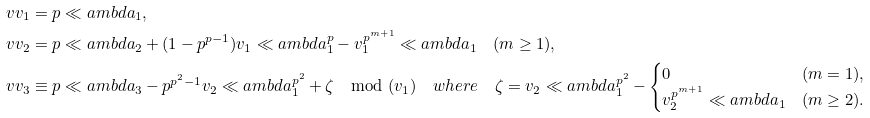Convert formula to latex. <formula><loc_0><loc_0><loc_500><loc_500>\ v v _ { 1 } & = p \ll a m b d a _ { 1 } , \\ \ v v _ { 2 } & = p \ll a m b d a _ { 2 } + ( 1 - p ^ { p - 1 } ) v _ { 1 } \ll a m b d a _ { 1 } ^ { p } - v _ { 1 } ^ { p ^ { m + 1 } } \ll a m b d a _ { 1 } \quad ( m \geq 1 ) , \\ \ v v _ { 3 } & \equiv p \ll a m b d a _ { 3 } - p ^ { p ^ { 2 } - 1 } v _ { 2 } \ll a m b d a _ { 1 } ^ { p ^ { 2 } } + \zeta \mod ( v _ { 1 } ) \quad w h e r e \quad \zeta = v _ { 2 } \ll a m b d a _ { 1 } ^ { p ^ { 2 } } - \begin{cases} 0 & ( m = 1 ) , \\ v _ { 2 } ^ { p ^ { m + 1 } } \ll a m b d a _ { 1 } & ( m \geq 2 ) . \end{cases}</formula> 